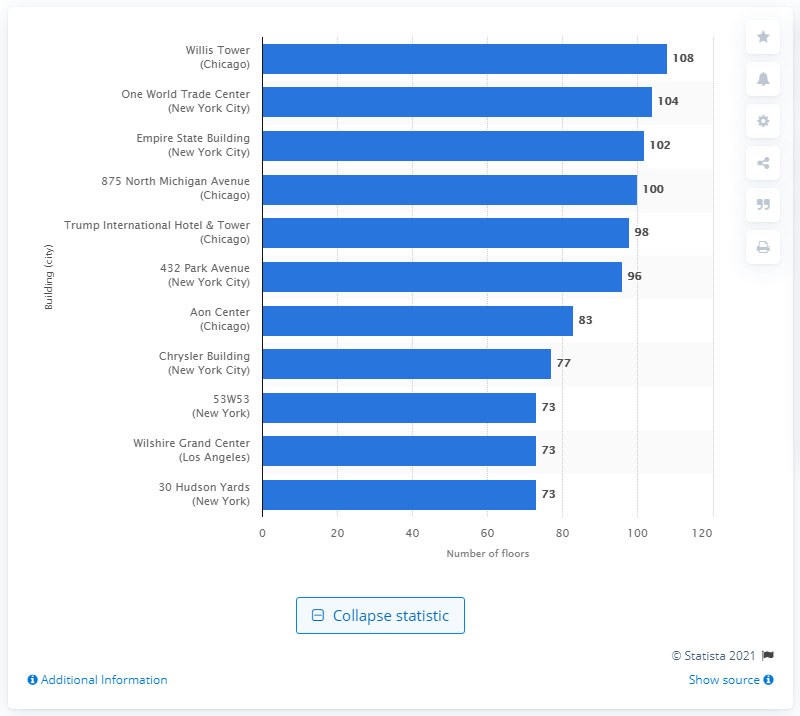Indicate a few pertinent items in this graphic. The Willis Tower has a total of 108 floors. 